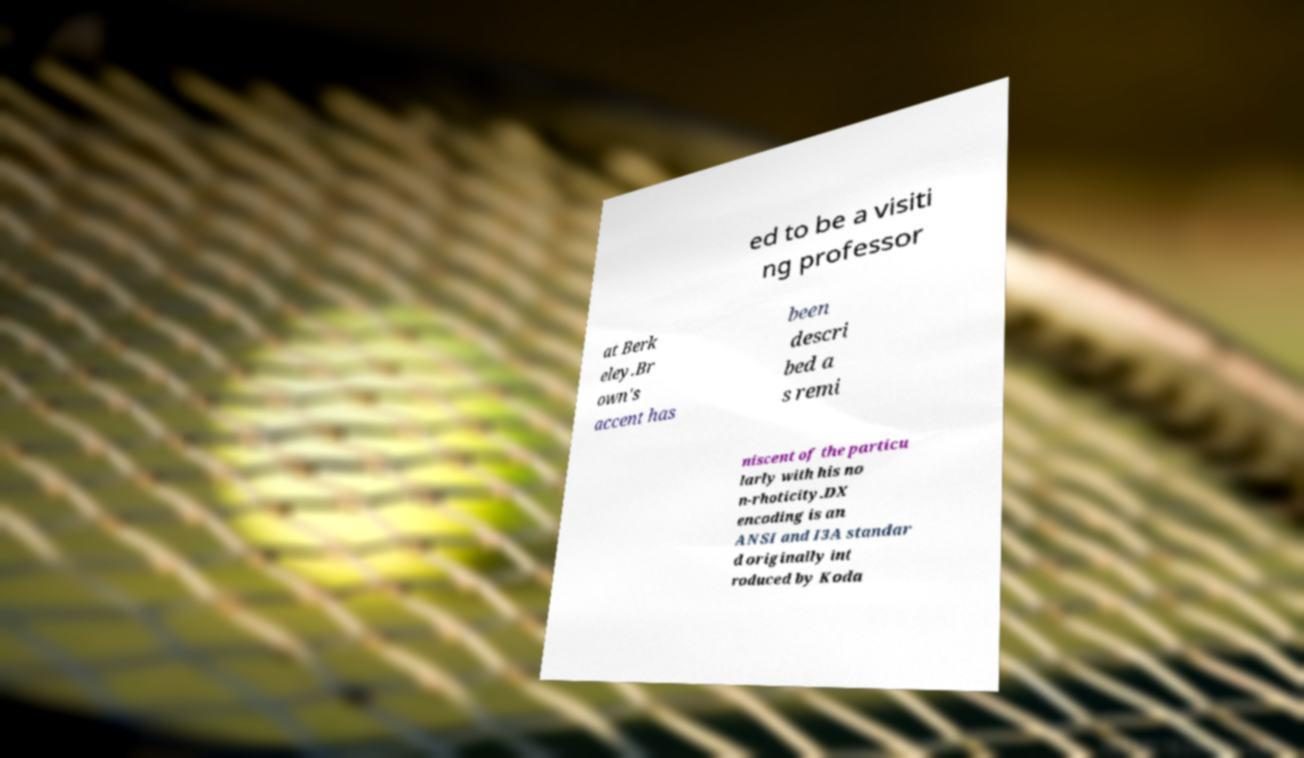Can you accurately transcribe the text from the provided image for me? ed to be a visiti ng professor at Berk eley.Br own's accent has been descri bed a s remi niscent of the particu larly with his no n-rhoticity.DX encoding is an ANSI and I3A standar d originally int roduced by Koda 